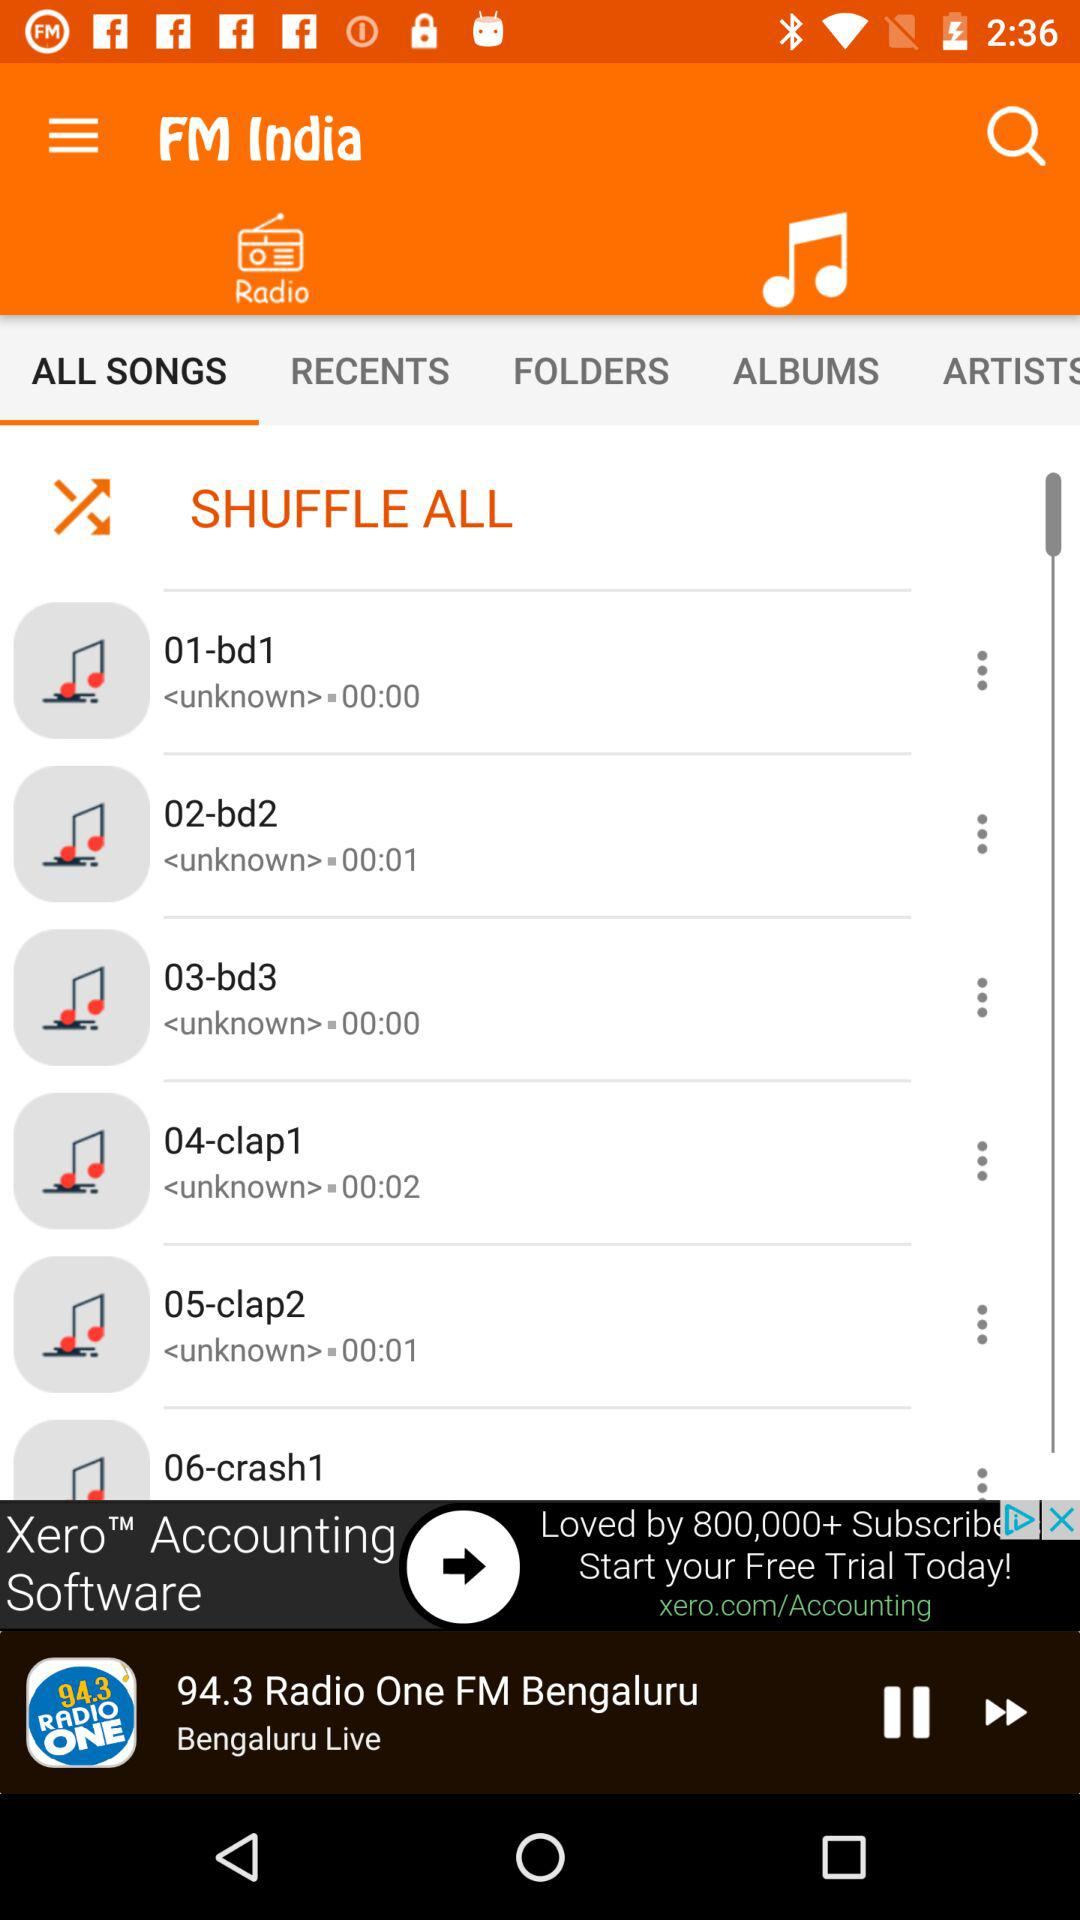Which tab is open? The open tabs are "Songs" and "ALL SONGS". 